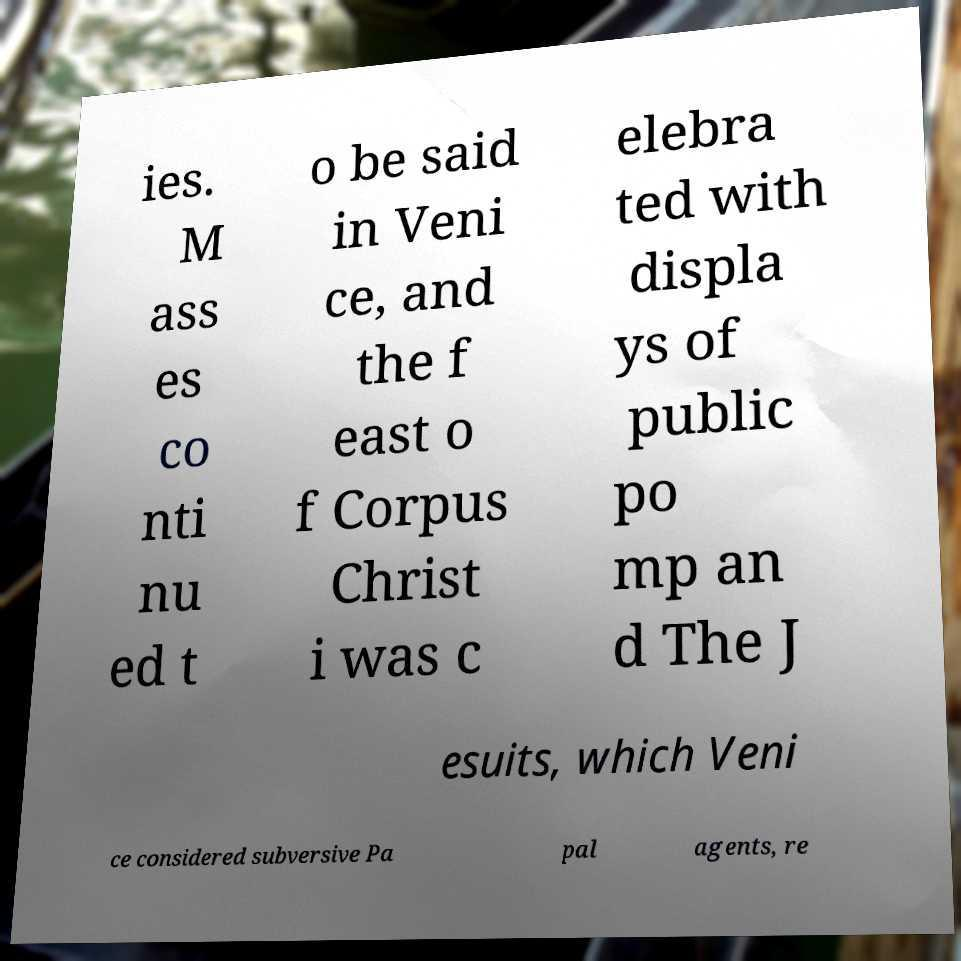Please identify and transcribe the text found in this image. ies. M ass es co nti nu ed t o be said in Veni ce, and the f east o f Corpus Christ i was c elebra ted with displa ys of public po mp an d The J esuits, which Veni ce considered subversive Pa pal agents, re 